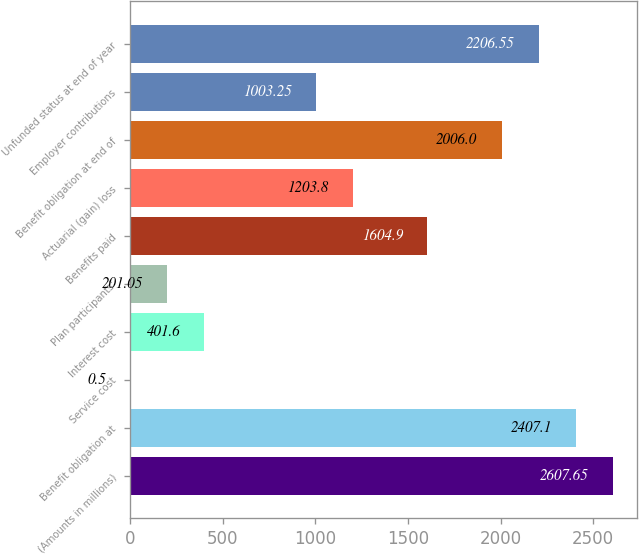<chart> <loc_0><loc_0><loc_500><loc_500><bar_chart><fcel>(Amounts in millions)<fcel>Benefit obligation at<fcel>Service cost<fcel>Interest cost<fcel>Plan participants'<fcel>Benefits paid<fcel>Actuarial (gain) loss<fcel>Benefit obligation at end of<fcel>Employer contributions<fcel>Unfunded status at end of year<nl><fcel>2607.65<fcel>2407.1<fcel>0.5<fcel>401.6<fcel>201.05<fcel>1604.9<fcel>1203.8<fcel>2006<fcel>1003.25<fcel>2206.55<nl></chart> 